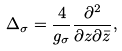<formula> <loc_0><loc_0><loc_500><loc_500>\Delta _ { \sigma } = { \frac { 4 } { g _ { \sigma } } } { \frac { \partial ^ { 2 } } { \partial z \partial \bar { z } } } ,</formula> 